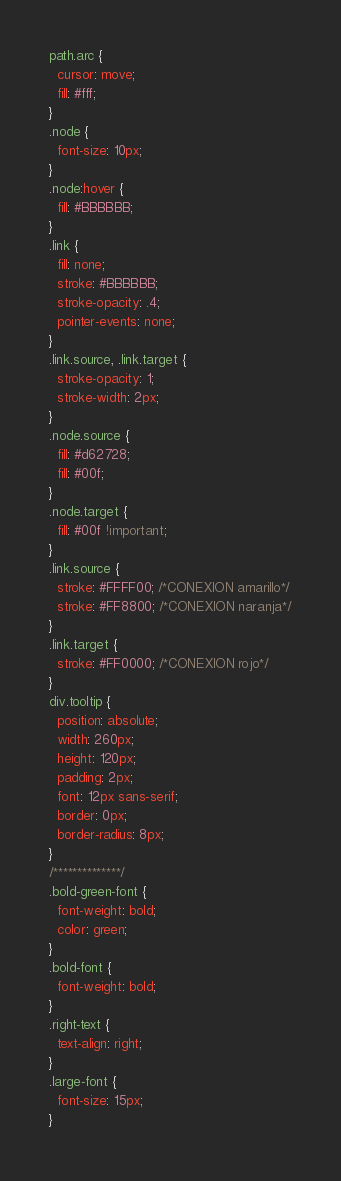Convert code to text. <code><loc_0><loc_0><loc_500><loc_500><_CSS_>path.arc {
  cursor: move;
  fill: #fff;
}
.node {
  font-size: 10px;
}
.node:hover {
  fill: #BBBBBB;
}
.link {
  fill: none;
  stroke: #BBBBBB;
  stroke-opacity: .4;
  pointer-events: none;
}
.link.source, .link.target {
  stroke-opacity: 1;
  stroke-width: 2px;
}
.node.source {
  fill: #d62728;
  fill: #00f;
}
.node.target {
  fill: #00f !important;
}
.link.source {
  stroke: #FFFF00; /*CONEXION amarillo*/
  stroke: #FF8800; /*CONEXION naranja*/
}
.link.target {
  stroke: #FF0000; /*CONEXION rojo*/
}
div.tooltip {
  position: absolute;
  width: 260px;
  height: 120px;
  padding: 2px;
  font: 12px sans-serif;
  border: 0px;
  border-radius: 8px;
}
/**************/
.bold-green-font {
  font-weight: bold;
  color: green;
}
.bold-font {
  font-weight: bold;
}
.right-text {
  text-align: right;
}
.large-font {
  font-size: 15px;
}</code> 